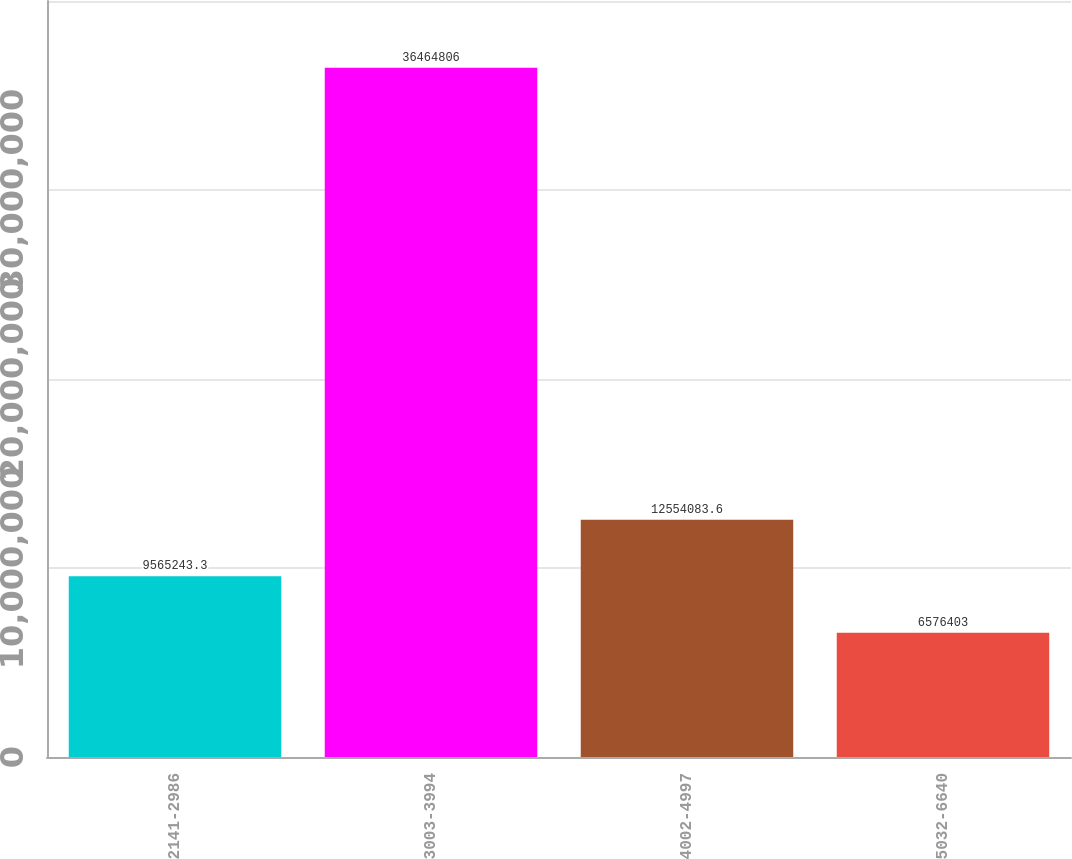<chart> <loc_0><loc_0><loc_500><loc_500><bar_chart><fcel>2141-2986<fcel>3003-3994<fcel>4002-4997<fcel>5032-6640<nl><fcel>9.56524e+06<fcel>3.64648e+07<fcel>1.25541e+07<fcel>6.5764e+06<nl></chart> 